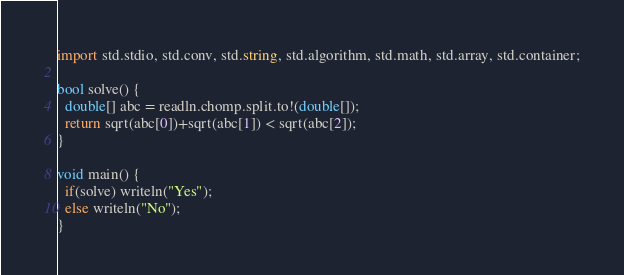Convert code to text. <code><loc_0><loc_0><loc_500><loc_500><_D_>import std.stdio, std.conv, std.string, std.algorithm, std.math, std.array, std.container;

bool solve() {
  double[] abc = readln.chomp.split.to!(double[]);
  return sqrt(abc[0])+sqrt(abc[1]) < sqrt(abc[2]);
}

void main() {
  if(solve) writeln("Yes");
  else writeln("No");
}

</code> 